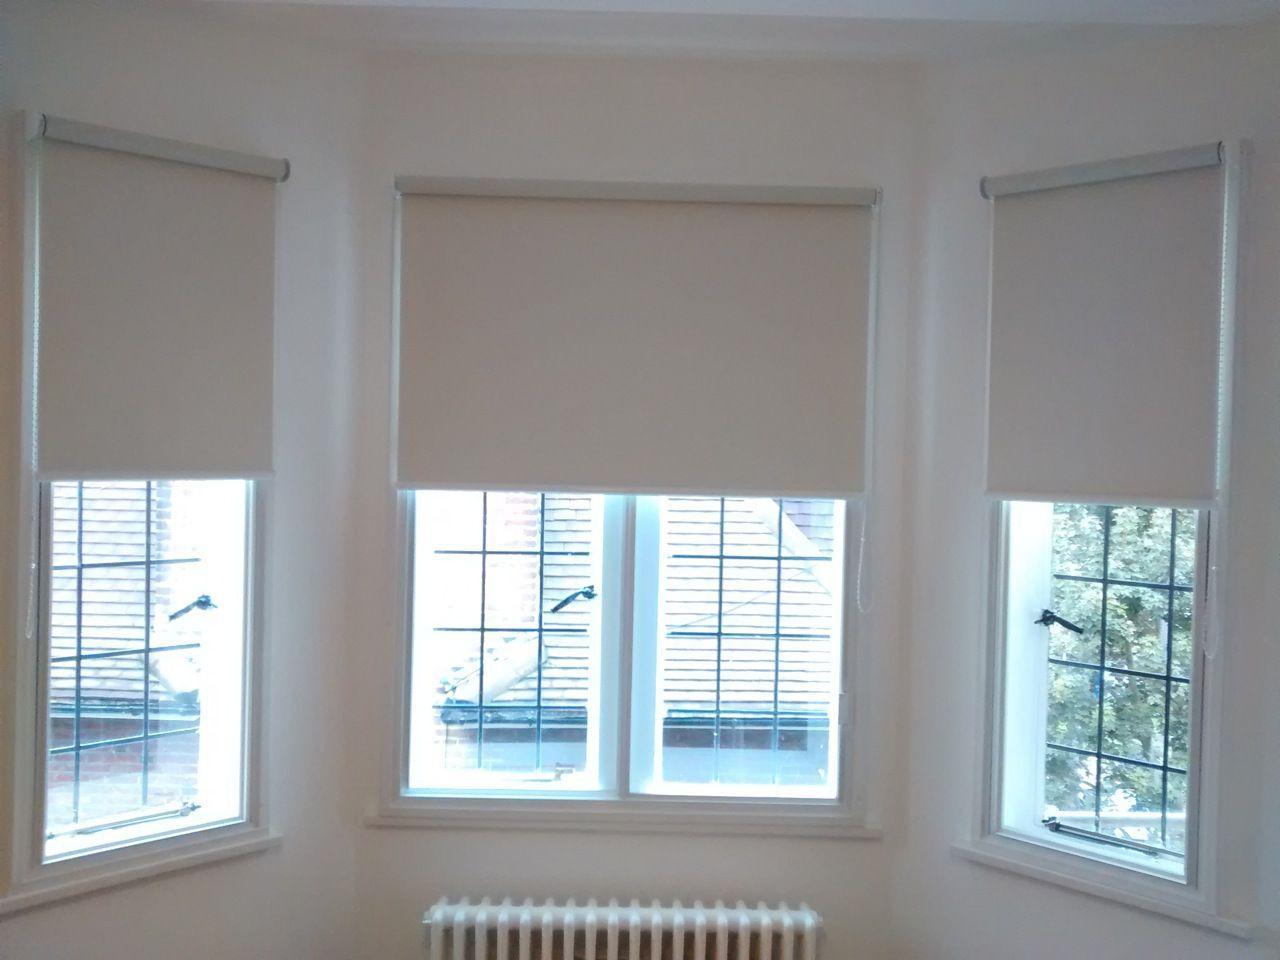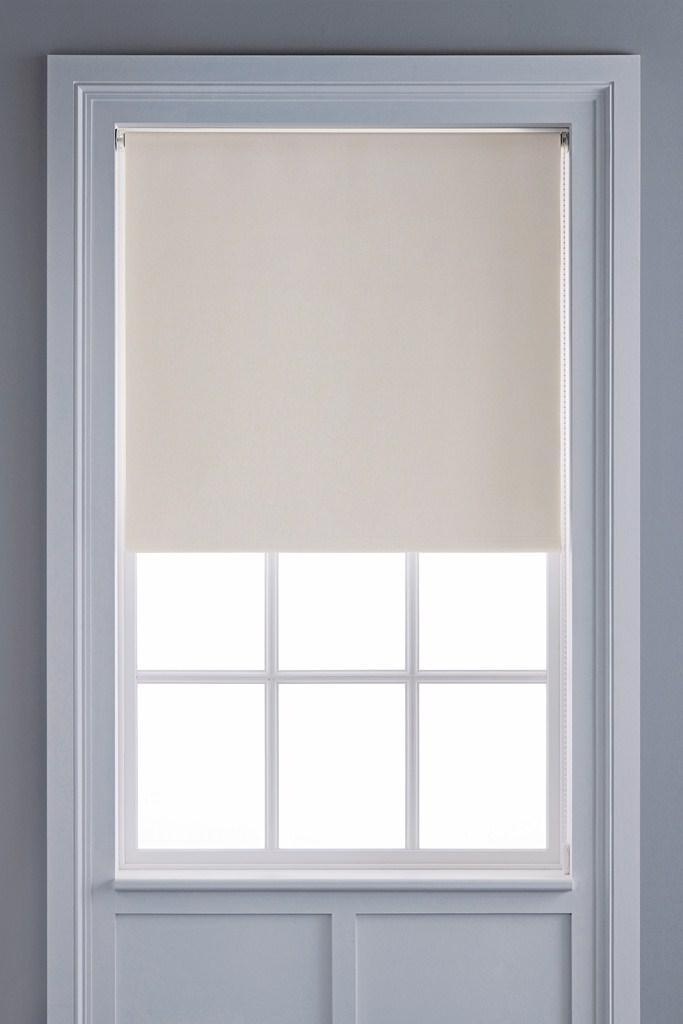The first image is the image on the left, the second image is the image on the right. For the images displayed, is the sentence "In at least one image there are three blue shades partly open." factually correct? Answer yes or no. No. The first image is the image on the left, the second image is the image on the right. Considering the images on both sides, is "One image is just a window, while the other is a room." valid? Answer yes or no. No. 